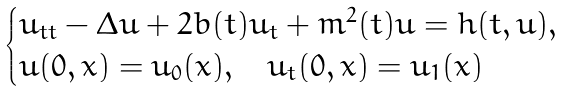<formula> <loc_0><loc_0><loc_500><loc_500>\begin{cases} u _ { t t } - \Delta u + 2 b ( t ) u _ { t } + m ^ { 2 } ( t ) u = h ( t , u ) , \\ u ( 0 , x ) = u _ { 0 } ( x ) , \quad u _ { t } ( 0 , x ) = u _ { 1 } ( x ) \end{cases}</formula> 